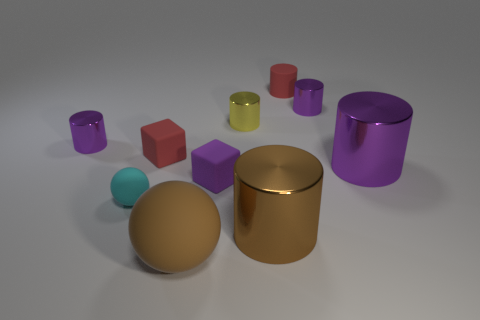The rubber thing that is behind the large purple metal object and right of the large sphere has what shape?
Give a very brief answer. Cylinder. There is a big rubber object; is it the same color as the small metal object right of the yellow cylinder?
Provide a short and direct response. No. There is a big metallic thing on the right side of the red thing that is behind the purple thing that is to the left of the cyan object; what color is it?
Make the answer very short. Purple. There is another rubber object that is the same shape as the tiny yellow object; what color is it?
Provide a short and direct response. Red. Is the number of cyan objects that are right of the small cyan matte ball the same as the number of tiny red cylinders?
Ensure brevity in your answer.  No. What number of cylinders are either large matte objects or purple shiny objects?
Provide a short and direct response. 3. What is the color of the small sphere that is made of the same material as the red cylinder?
Offer a terse response. Cyan. Are the small red cylinder and the big cylinder on the right side of the red cylinder made of the same material?
Provide a short and direct response. No. What number of objects are either matte spheres or brown objects?
Give a very brief answer. 3. There is a cylinder that is the same color as the big rubber sphere; what material is it?
Offer a terse response. Metal. 